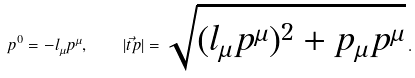Convert formula to latex. <formula><loc_0><loc_0><loc_500><loc_500>p ^ { 0 } = - l _ { \mu } p ^ { \mu } , \quad | \vec { t } p | = \sqrt { ( l _ { \mu } p ^ { \mu } ) ^ { 2 } + p _ { \mu } p ^ { \mu } } \, .</formula> 